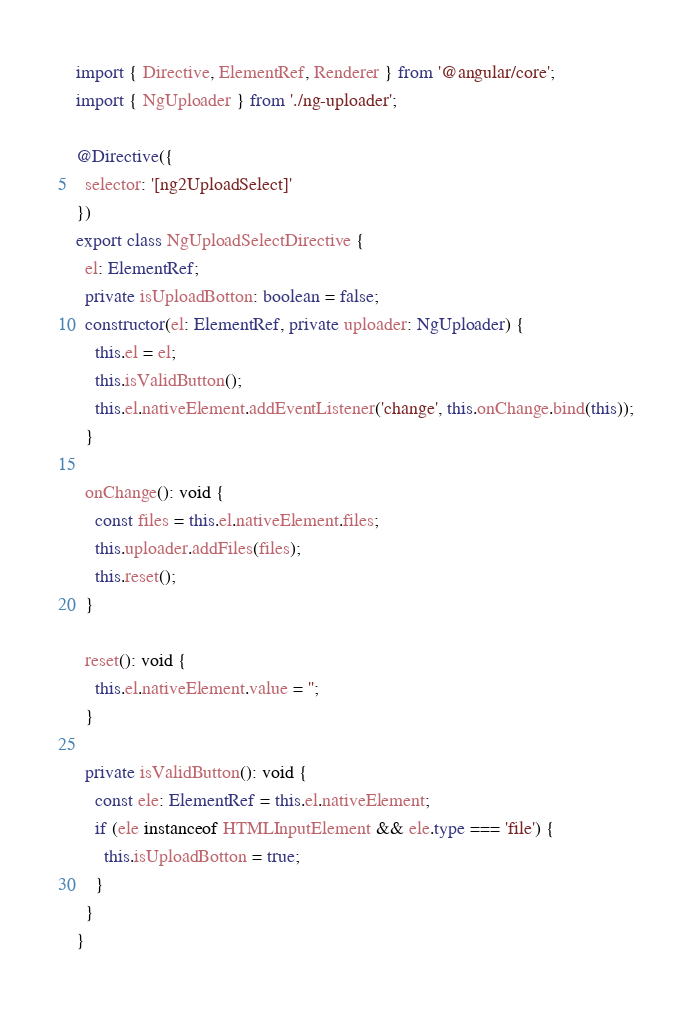Convert code to text. <code><loc_0><loc_0><loc_500><loc_500><_TypeScript_>import { Directive, ElementRef, Renderer } from '@angular/core';
import { NgUploader } from './ng-uploader';

@Directive({
  selector: '[ng2UploadSelect]'
})
export class NgUploadSelectDirective {
  el: ElementRef;
  private isUploadBotton: boolean = false;
  constructor(el: ElementRef, private uploader: NgUploader) {
    this.el = el;
    this.isValidButton();
    this.el.nativeElement.addEventListener('change', this.onChange.bind(this));
  }

  onChange(): void {
    const files = this.el.nativeElement.files;
    this.uploader.addFiles(files);
    this.reset();
  }

  reset(): void {
    this.el.nativeElement.value = '';
  }

  private isValidButton(): void {
    const ele: ElementRef = this.el.nativeElement;
    if (ele instanceof HTMLInputElement && ele.type === 'file') {
      this.isUploadBotton = true;
    }
  }
}</code> 